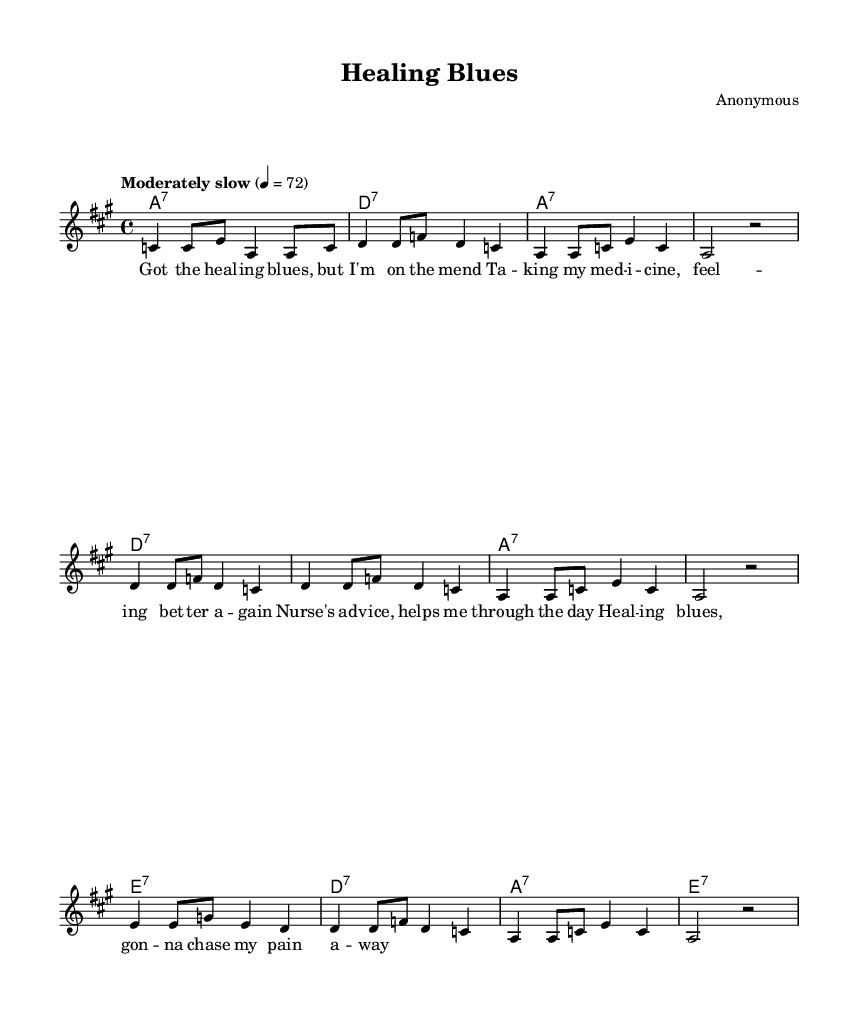What is the key signature of this music? The key signature indicates that the piece is in A major, which has three sharps (F#, C#, and G#). This can be identified from the global section of the LilyPond code where it specifies \key a \major.
Answer: A major What is the time signature of this music? The time signature is found in the global section of the music sheet and is shown as 4/4, which means there are four beats in each measure and the quarter note gets one beat.
Answer: 4/4 What is the tempo marking for this piece? The tempo marking is indicated as "Moderately slow" with a metronome marking of 72 beats per minute, which can be seen in the global section. This indicates the speed at which the piece should be played.
Answer: Moderately slow How many measures are in the melody? By counting the number of line breaks in the melody section of the score, we find that there are a total of 8 measures. Each distinct grouping of notes within vertical lines represents one measure.
Answer: 8 What is the primary theme reflected in the lyrics? The lyrics express themes of healing and recovery, as evidenced by phrases like "Got the healing blues" and "gonna chase my pain away." This reflects the overall sentiment of overcoming adversity through support and medicine, which is integral to the blues genre.
Answer: Healing What is the structure of the harmonies used in this piece? The structure of the harmonies follows a pattern of repeated seventh chords: A7, D7, and E7. This cyclical structure is common in blues music, which often utilizes 12-bar patterns that alternate between these chords.
Answer: A7, D7, E7 